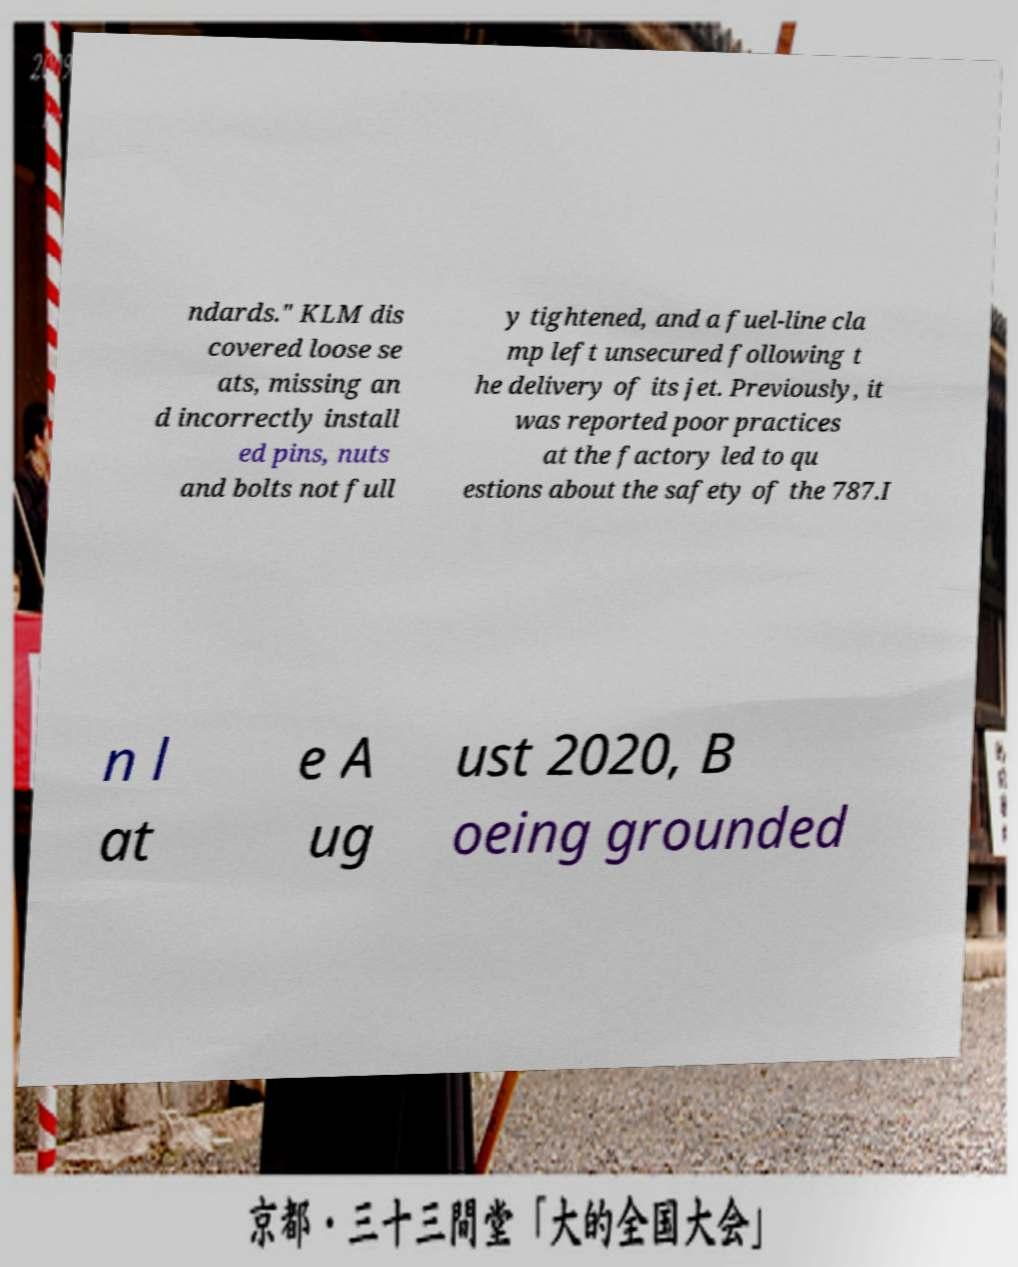Could you extract and type out the text from this image? ndards." KLM dis covered loose se ats, missing an d incorrectly install ed pins, nuts and bolts not full y tightened, and a fuel-line cla mp left unsecured following t he delivery of its jet. Previously, it was reported poor practices at the factory led to qu estions about the safety of the 787.I n l at e A ug ust 2020, B oeing grounded 